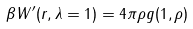Convert formula to latex. <formula><loc_0><loc_0><loc_500><loc_500>\beta W ^ { \prime } ( r , \lambda = 1 ) = 4 \pi \rho g ( 1 , \rho )</formula> 